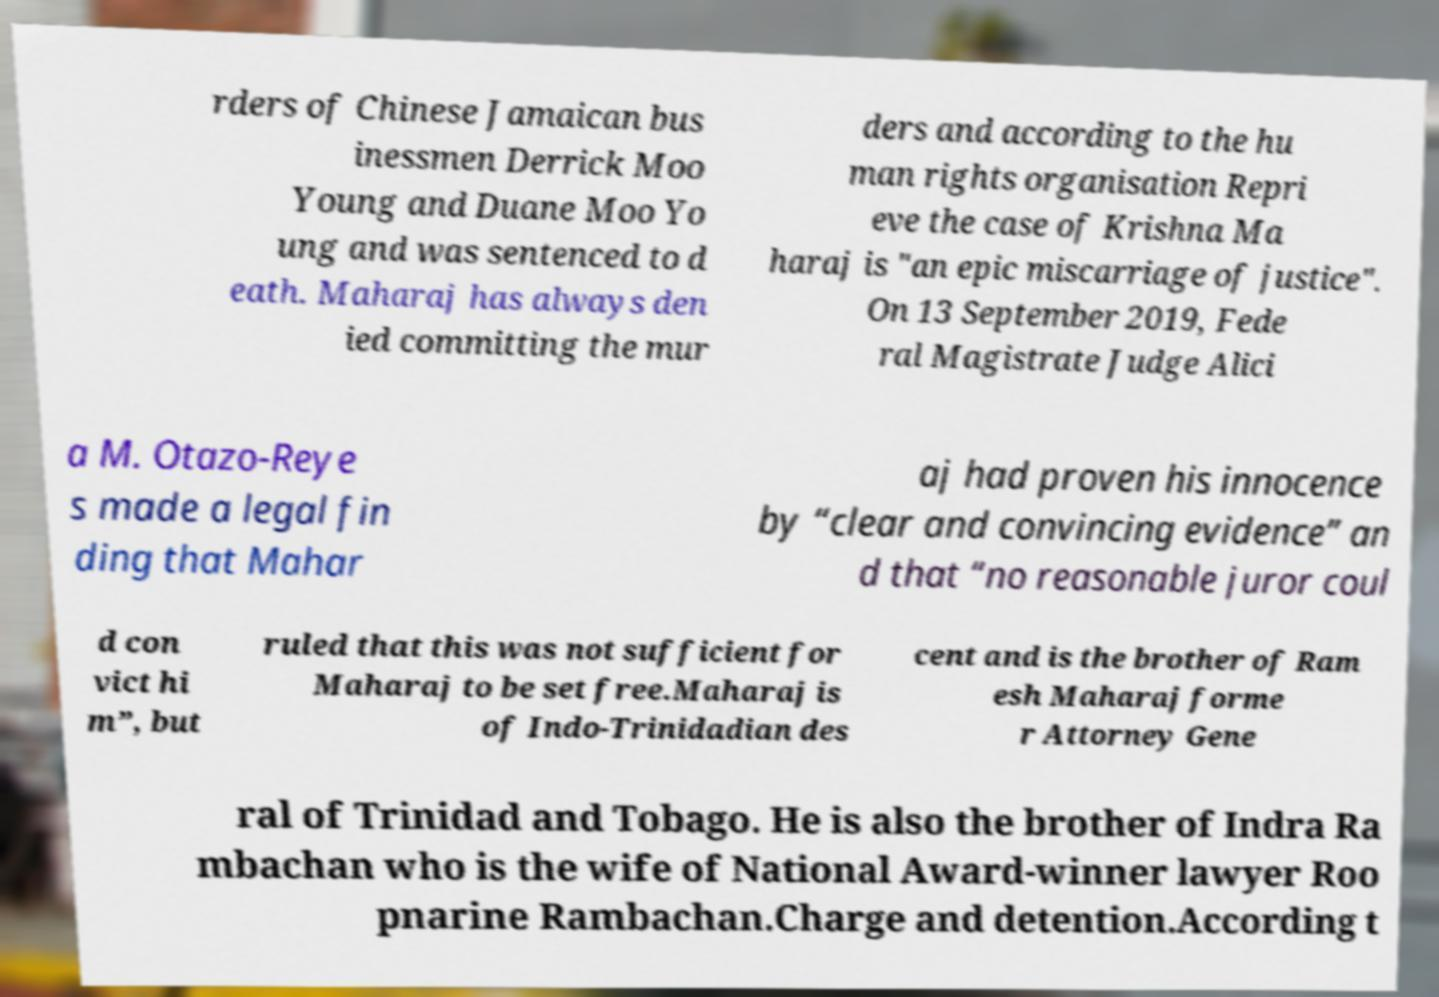Can you accurately transcribe the text from the provided image for me? rders of Chinese Jamaican bus inessmen Derrick Moo Young and Duane Moo Yo ung and was sentenced to d eath. Maharaj has always den ied committing the mur ders and according to the hu man rights organisation Repri eve the case of Krishna Ma haraj is "an epic miscarriage of justice". On 13 September 2019, Fede ral Magistrate Judge Alici a M. Otazo-Reye s made a legal fin ding that Mahar aj had proven his innocence by “clear and convincing evidence” an d that “no reasonable juror coul d con vict hi m”, but ruled that this was not sufficient for Maharaj to be set free.Maharaj is of Indo-Trinidadian des cent and is the brother of Ram esh Maharaj forme r Attorney Gene ral of Trinidad and Tobago. He is also the brother of Indra Ra mbachan who is the wife of National Award-winner lawyer Roo pnarine Rambachan.Charge and detention.According t 